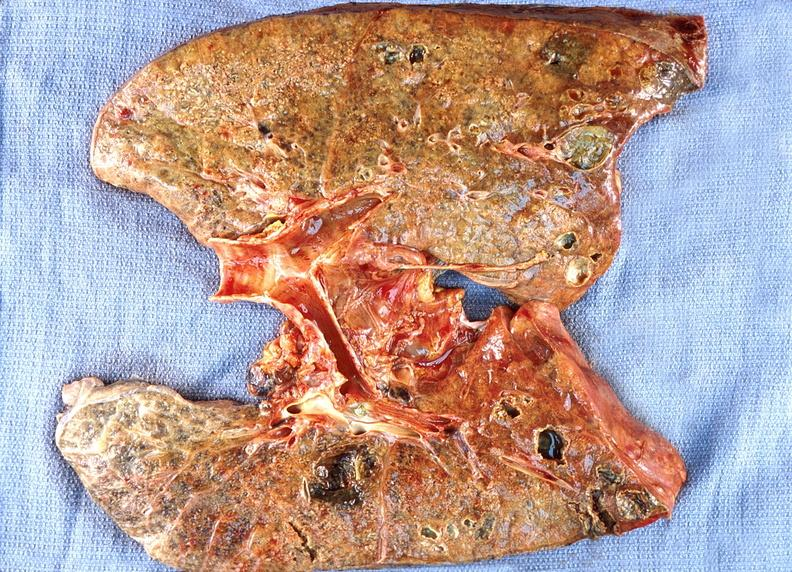what is present?
Answer the question using a single word or phrase. Respiratory 